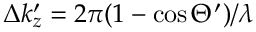<formula> <loc_0><loc_0><loc_500><loc_500>\Delta k _ { z } ^ { \prime } = 2 \pi ( 1 - \cos \Theta ^ { \prime } ) / \lambda</formula> 